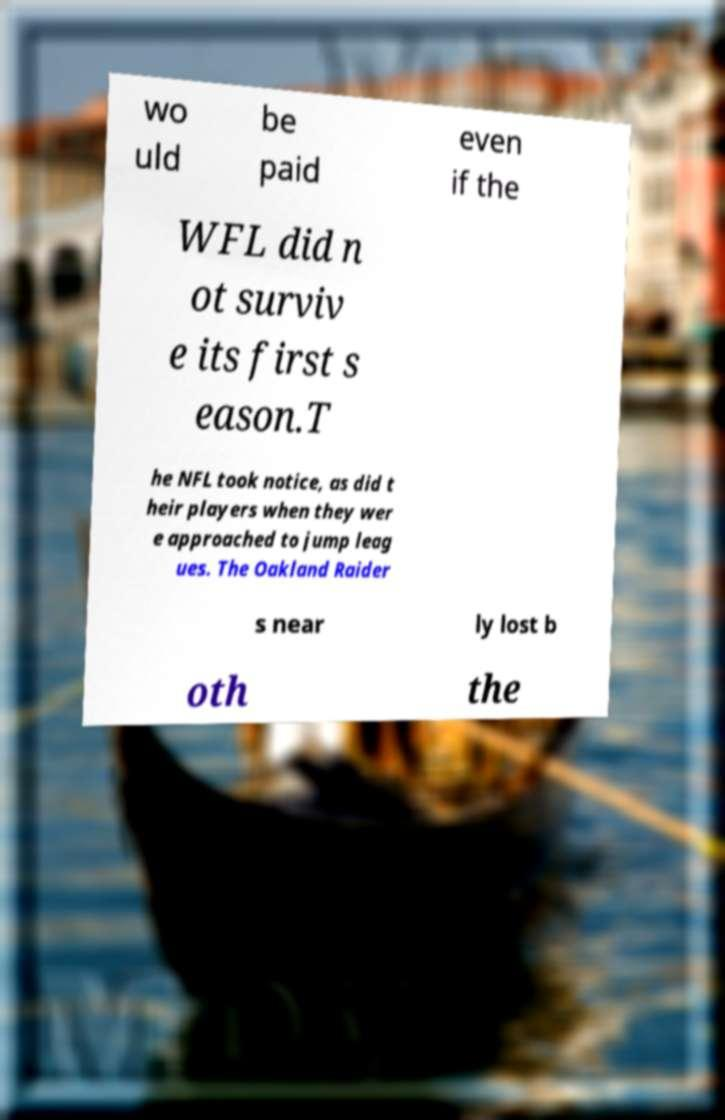There's text embedded in this image that I need extracted. Can you transcribe it verbatim? wo uld be paid even if the WFL did n ot surviv e its first s eason.T he NFL took notice, as did t heir players when they wer e approached to jump leag ues. The Oakland Raider s near ly lost b oth the 